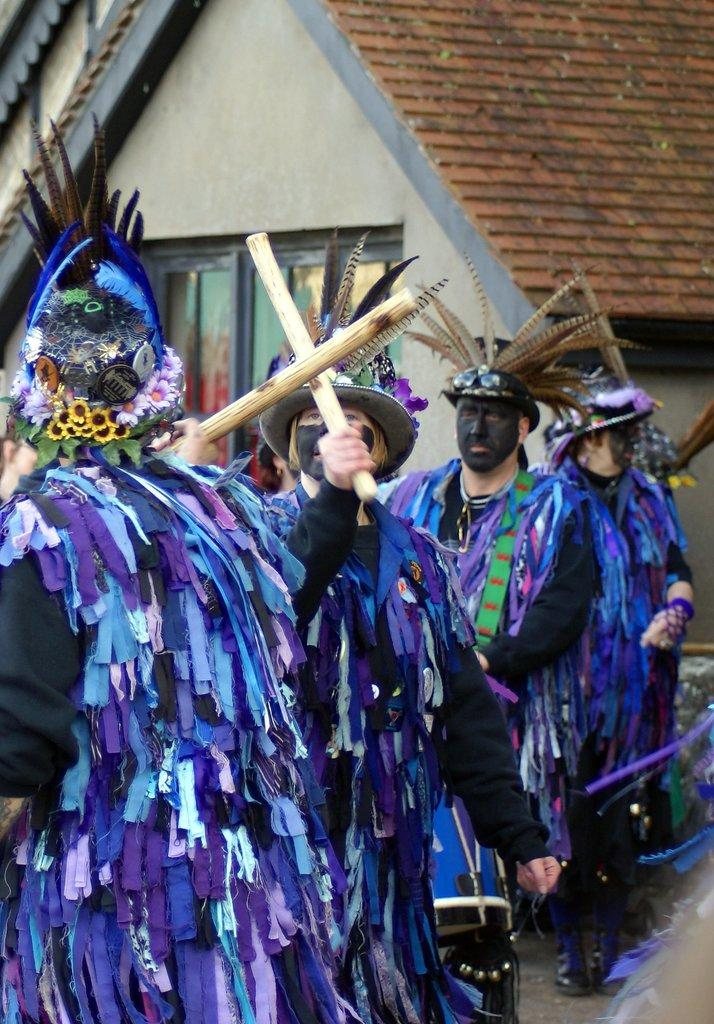What is happening in the image involving the people? The people in the image are standing and playing with sticks. What are the people wearing in the image? The people are wearing blue color clothes. What structure can be seen in the image? There is a house in the image. Can you see any spots on the people's clothes in the image? There is no mention of spots on the people's clothes in the image, so we cannot determine if any are present. 